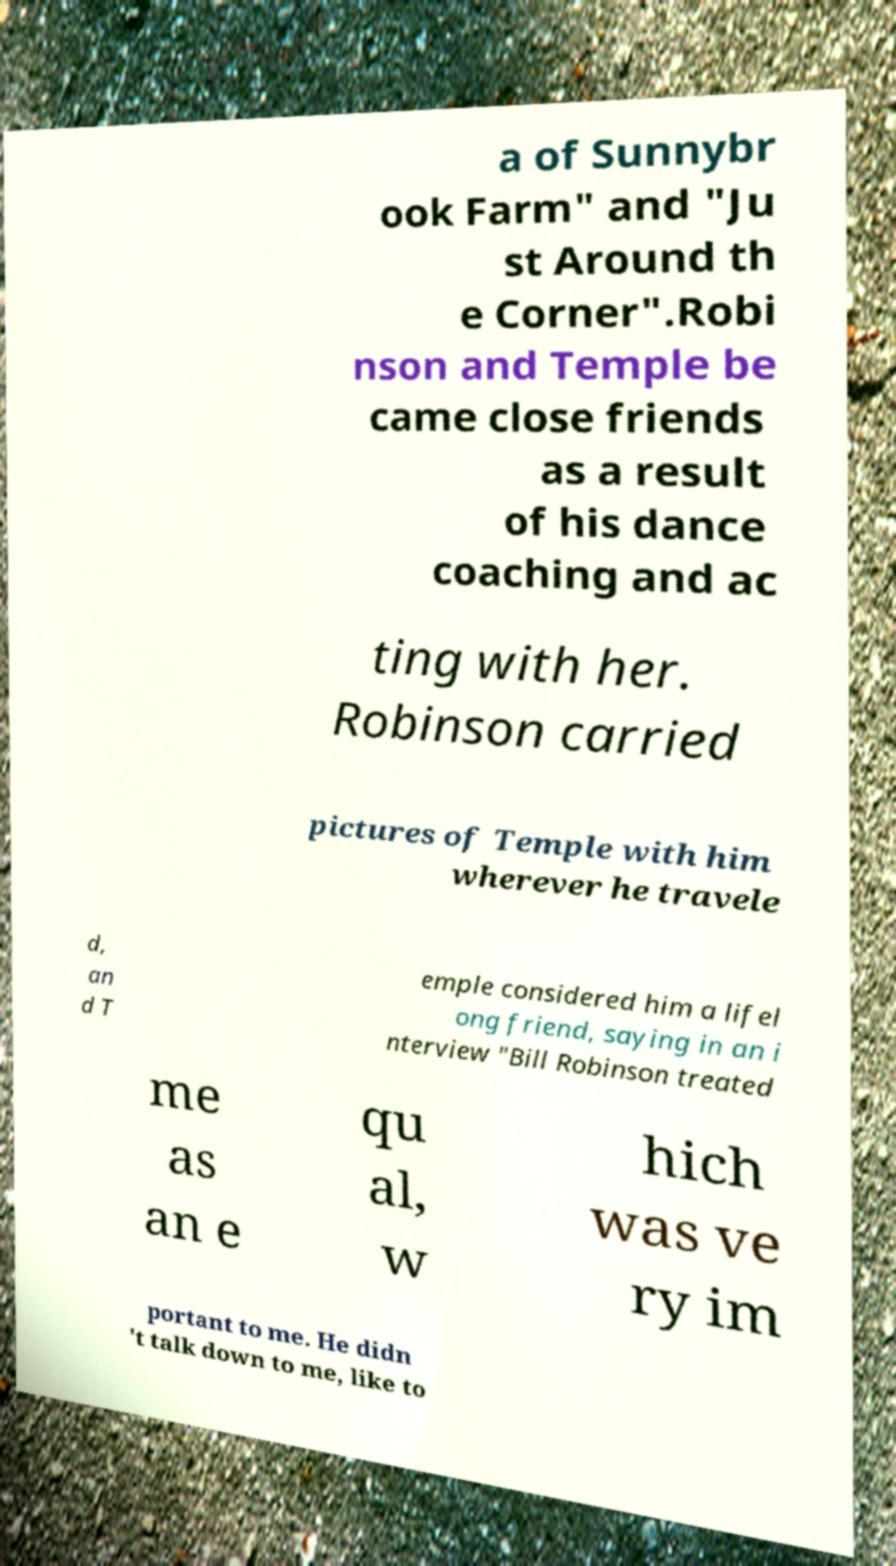Please read and relay the text visible in this image. What does it say? a of Sunnybr ook Farm" and "Ju st Around th e Corner".Robi nson and Temple be came close friends as a result of his dance coaching and ac ting with her. Robinson carried pictures of Temple with him wherever he travele d, an d T emple considered him a lifel ong friend, saying in an i nterview "Bill Robinson treated me as an e qu al, w hich was ve ry im portant to me. He didn 't talk down to me, like to 